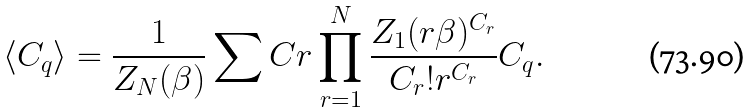Convert formula to latex. <formula><loc_0><loc_0><loc_500><loc_500>\langle C _ { q } \rangle = \frac { 1 } { Z _ { N } ( \beta ) } \sum C r \prod _ { r = 1 } ^ { N } \frac { Z _ { 1 } ( r \beta ) ^ { C _ { r } } } { C _ { r } ! r ^ { C _ { r } } } C _ { q } .</formula> 